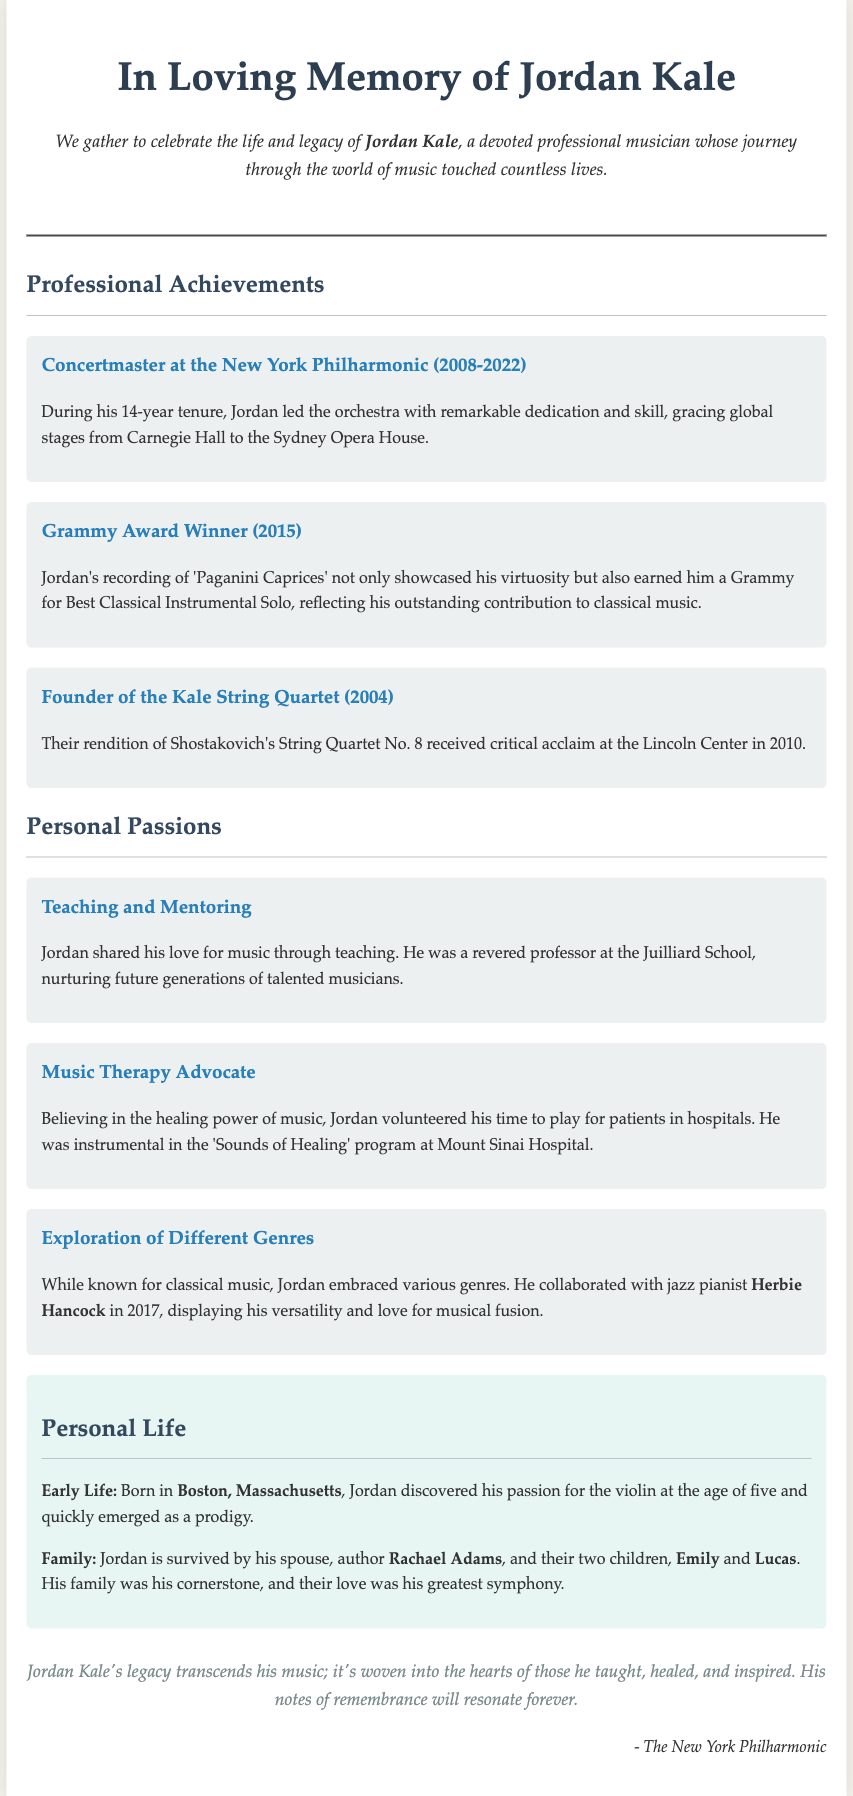What is the primary occupation of Jordan Kale? The document describes Jordan Kale as a devoted professional musician, primarily recognized for his contributions to classical music.
Answer: professional musician When did Jordan serve as concertmaster at the New York Philharmonic? The document states that Jordan was the concertmaster from 2008 to 2022.
Answer: 2008-2022 What prestigious award did Jordan win in 2015? The obituary mentions that he won a Grammy Award for his recording of 'Paganini Caprices'.
Answer: Grammy Award Who was Jordan's notable collaborator in 2017? The document notes that he collaborated with jazz pianist Herbie Hancock in 2017.
Answer: Herbie Hancock What was the name of the string quartet founded by Jordan? The obituary highlights that he founded the Kale String Quartet.
Answer: Kale String Quartet What significant role did Jordan have at the Juilliard School? The document explains that Jordan was a revered professor at the Juilliard School, indicating his involvement in education.
Answer: professor How did Jordan contribute to music therapy? According to the obituary, he volunteered his time to play for patients in hospitals, specifically through the 'Sounds of Healing' program.
Answer: Sounds of Healing What city was Jordan Kale born in? The document identifies Boston, Massachusetts, as Jordan's birthplace.
Answer: Boston, Massachusetts Who survives Jordan Kale? The obituary states that he is survived by his spouse, Rachael Adams, and their two children, Emily and Lucas.
Answer: Rachael Adams, Emily, and Lucas 